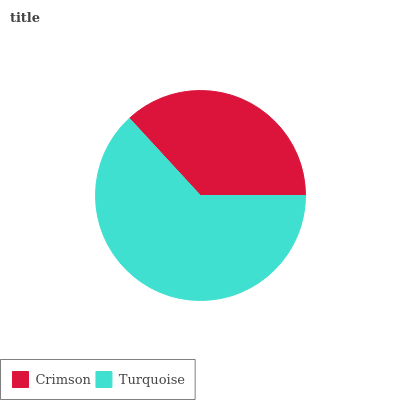Is Crimson the minimum?
Answer yes or no. Yes. Is Turquoise the maximum?
Answer yes or no. Yes. Is Turquoise the minimum?
Answer yes or no. No. Is Turquoise greater than Crimson?
Answer yes or no. Yes. Is Crimson less than Turquoise?
Answer yes or no. Yes. Is Crimson greater than Turquoise?
Answer yes or no. No. Is Turquoise less than Crimson?
Answer yes or no. No. Is Turquoise the high median?
Answer yes or no. Yes. Is Crimson the low median?
Answer yes or no. Yes. Is Crimson the high median?
Answer yes or no. No. Is Turquoise the low median?
Answer yes or no. No. 